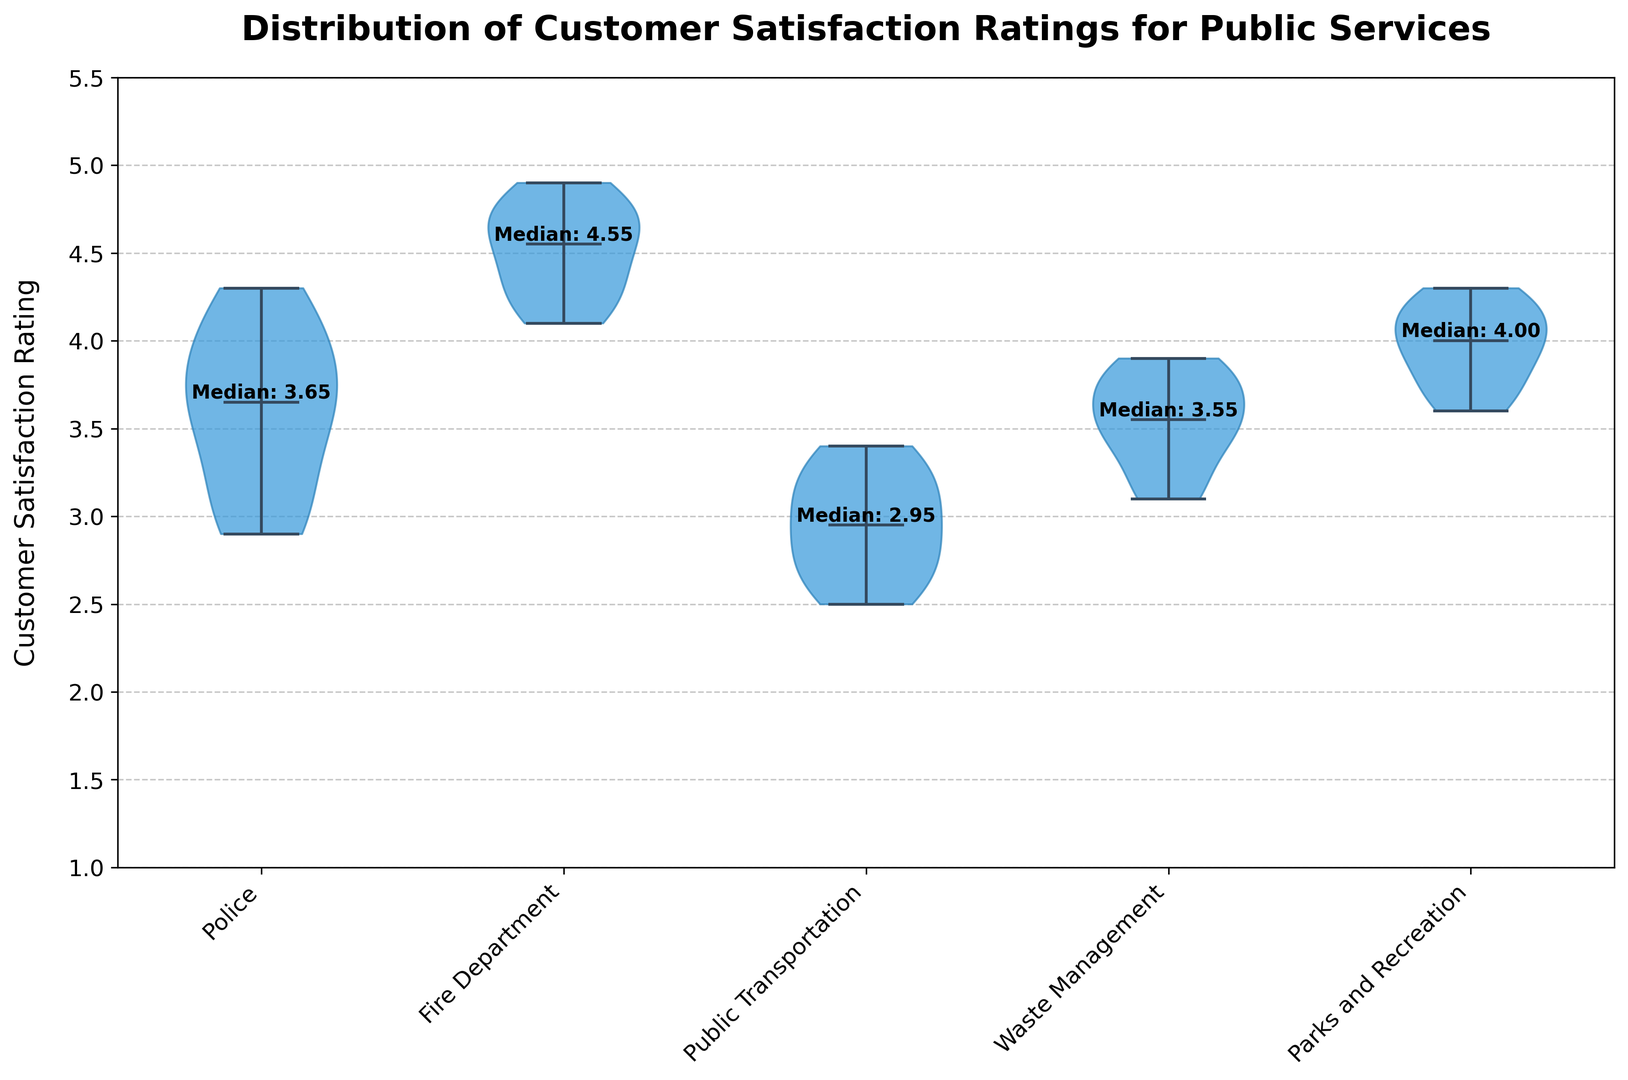What is the median customer satisfaction rating for Police? The figure shows the distribution of customer satisfaction ratings for each service. For the Police, locate the text annotation at the Police violin plot. It indicates the median rating.
Answer: 3.6 Which service has the highest median customer satisfaction rating? By examining the median annotations for all the services in the figure, identify the service with the highest median rating. The Fire Department's median rating is the highest.
Answer: Fire Department Compare the spread of customer satisfaction ratings between Public Transportation and Parks and Recreation. Which one shows a wider spread? Observe the width and shape of the violin plots for both Public Transportation and Parks and Recreation. The Public Transportation violin plot is wider, indicating a broader spread of ratings.
Answer: Public Transportation What is the most frequent customer satisfaction rating range for Waste Management? Look at the shape of the violin plot for Waste Management to determine where the plot is the widest, which suggests the most frequent rating range. The widest part is around ratings of 3.5 to 3.8.
Answer: 3.5 to 3.8 Does any service's distribution show multiple peaks? If so, which one(s)? Examine the violin plots for any that have more than one peak, indicating multimodal distribution. None of the services display multiple peaks; they all show a single peak indicating unimodal distributions.
Answer: None Calculate the difference between the highest and lowest median customer satisfaction ratings among the services. Identify the highest median rating (Fire Department with 4.5) and the lowest median rating (Public Transportation with 2.9) from the figure. Subtract the lowest median from the highest median. 4.5 - 2.9 = 1.6
Answer: 1.6 Which service has the least variability in customer satisfaction ratings? Look at the violin plots to identify which one is the narrowest, as narrowness denotes less variability. The Fire Department's violin plot is the narrowest.
Answer: Fire Department 